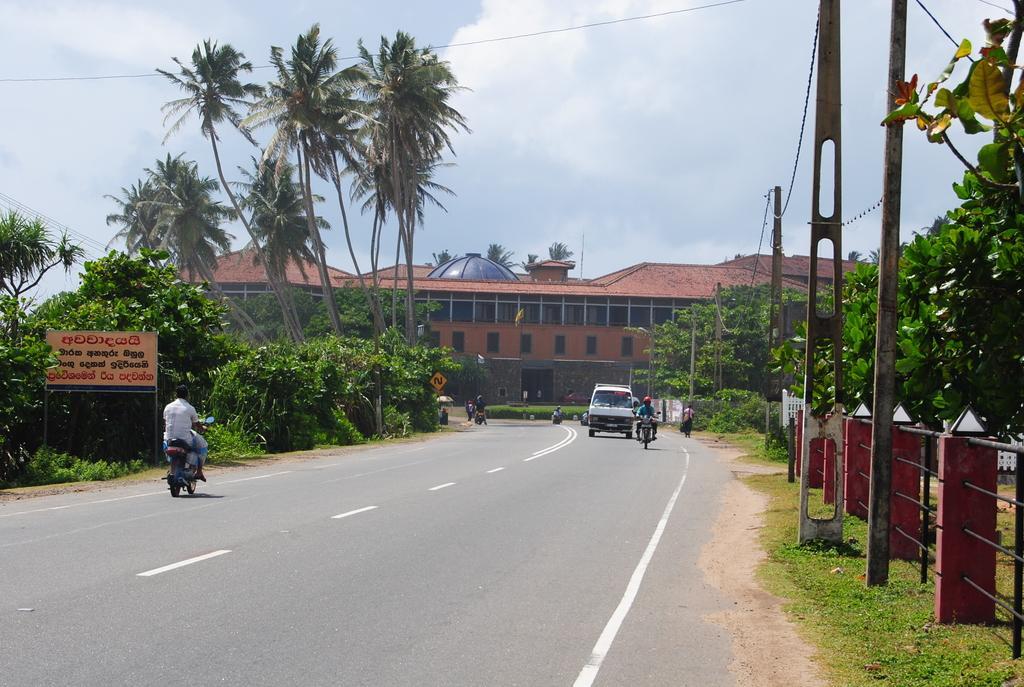Could you give a brief overview of what you see in this image? In this image there is a road on which there are vehicles. In the background there is a building. There are trees on either side of the road. At the top there is the sky. On the footpath there are electric poles through which wires are connected. On the left side there is a board on the footpath. 